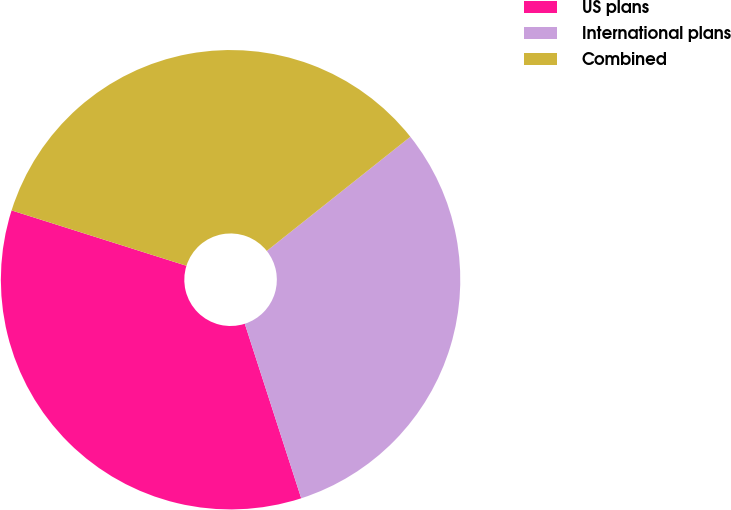Convert chart to OTSL. <chart><loc_0><loc_0><loc_500><loc_500><pie_chart><fcel>US plans<fcel>International plans<fcel>Combined<nl><fcel>34.86%<fcel>30.72%<fcel>34.43%<nl></chart> 